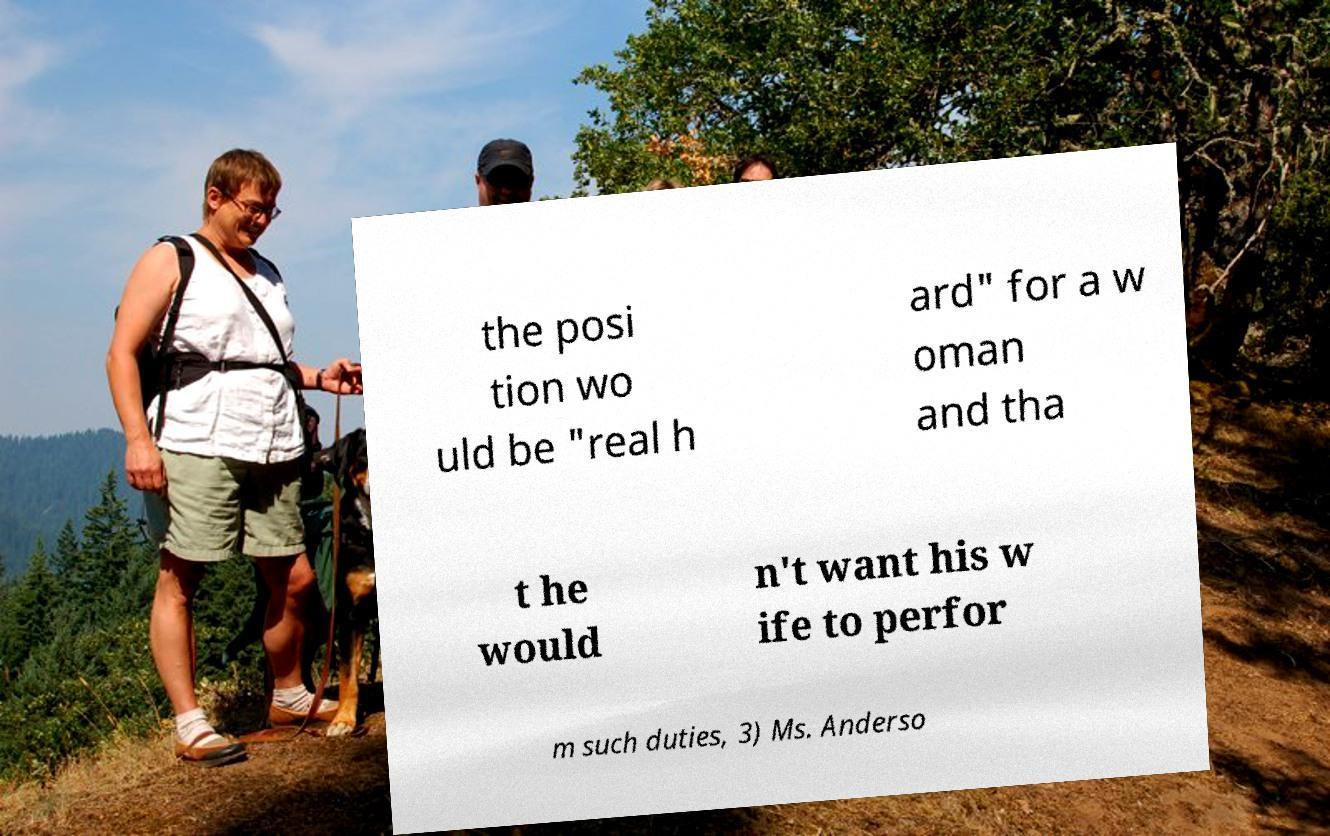Please read and relay the text visible in this image. What does it say? the posi tion wo uld be "real h ard" for a w oman and tha t he would n't want his w ife to perfor m such duties, 3) Ms. Anderso 